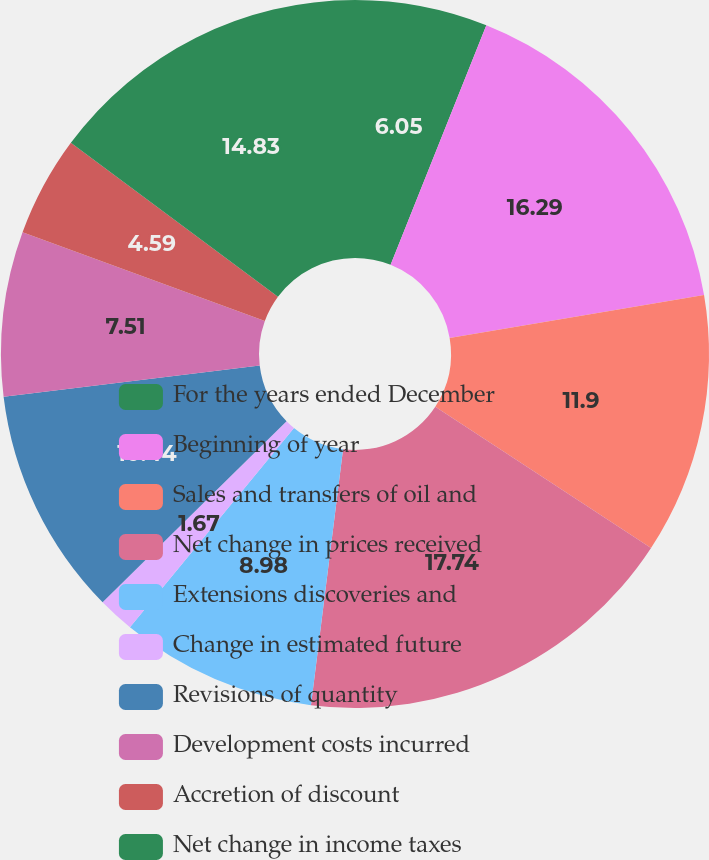Convert chart to OTSL. <chart><loc_0><loc_0><loc_500><loc_500><pie_chart><fcel>For the years ended December<fcel>Beginning of year<fcel>Sales and transfers of oil and<fcel>Net change in prices received<fcel>Extensions discoveries and<fcel>Change in estimated future<fcel>Revisions of quantity<fcel>Development costs incurred<fcel>Accretion of discount<fcel>Net change in income taxes<nl><fcel>6.05%<fcel>16.29%<fcel>11.9%<fcel>17.75%<fcel>8.98%<fcel>1.67%<fcel>10.44%<fcel>7.51%<fcel>4.59%<fcel>14.83%<nl></chart> 